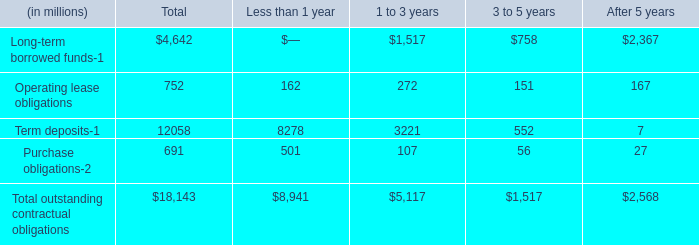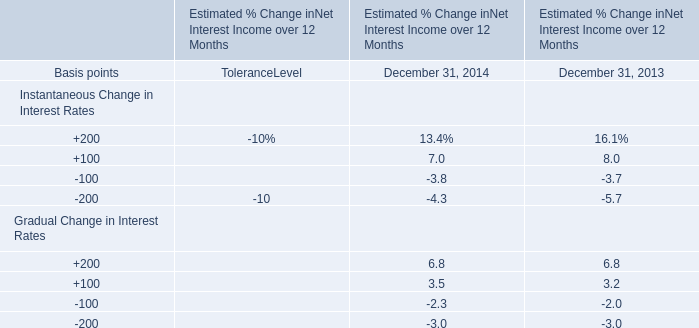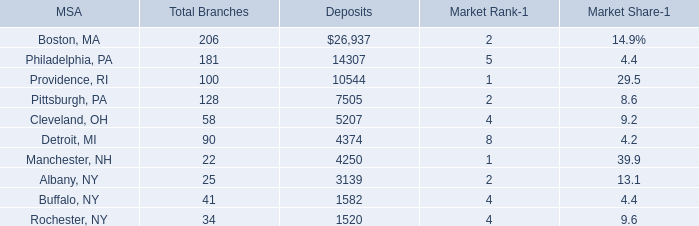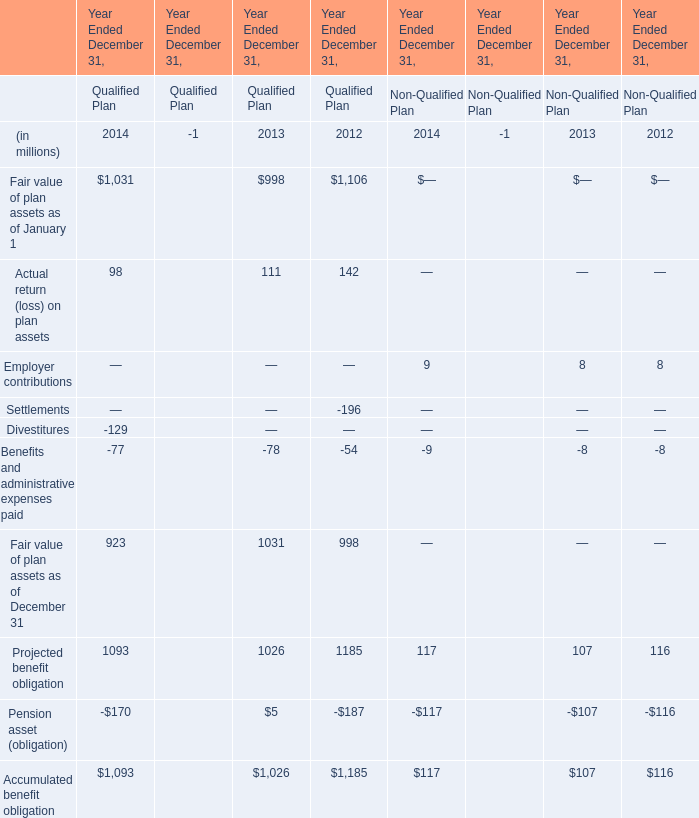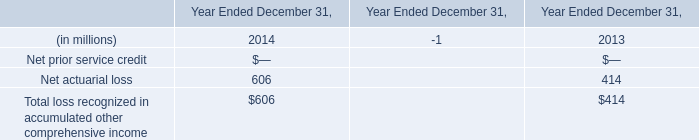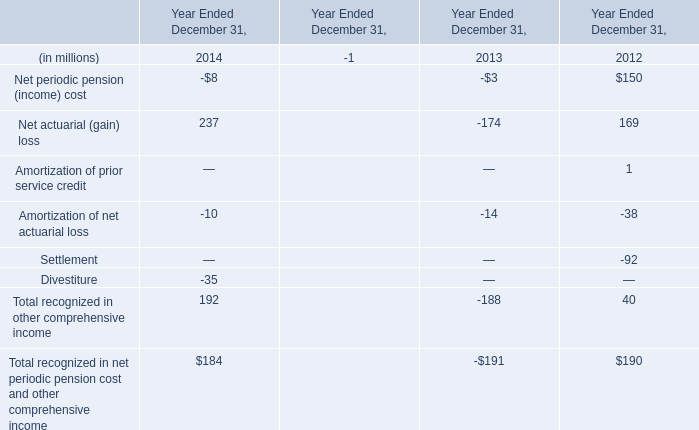What's the average of the Projected benefit obligation in the years where Pension asset (obligation) for Qualified Plan is positive? (in millions) 
Answer: 1026. 